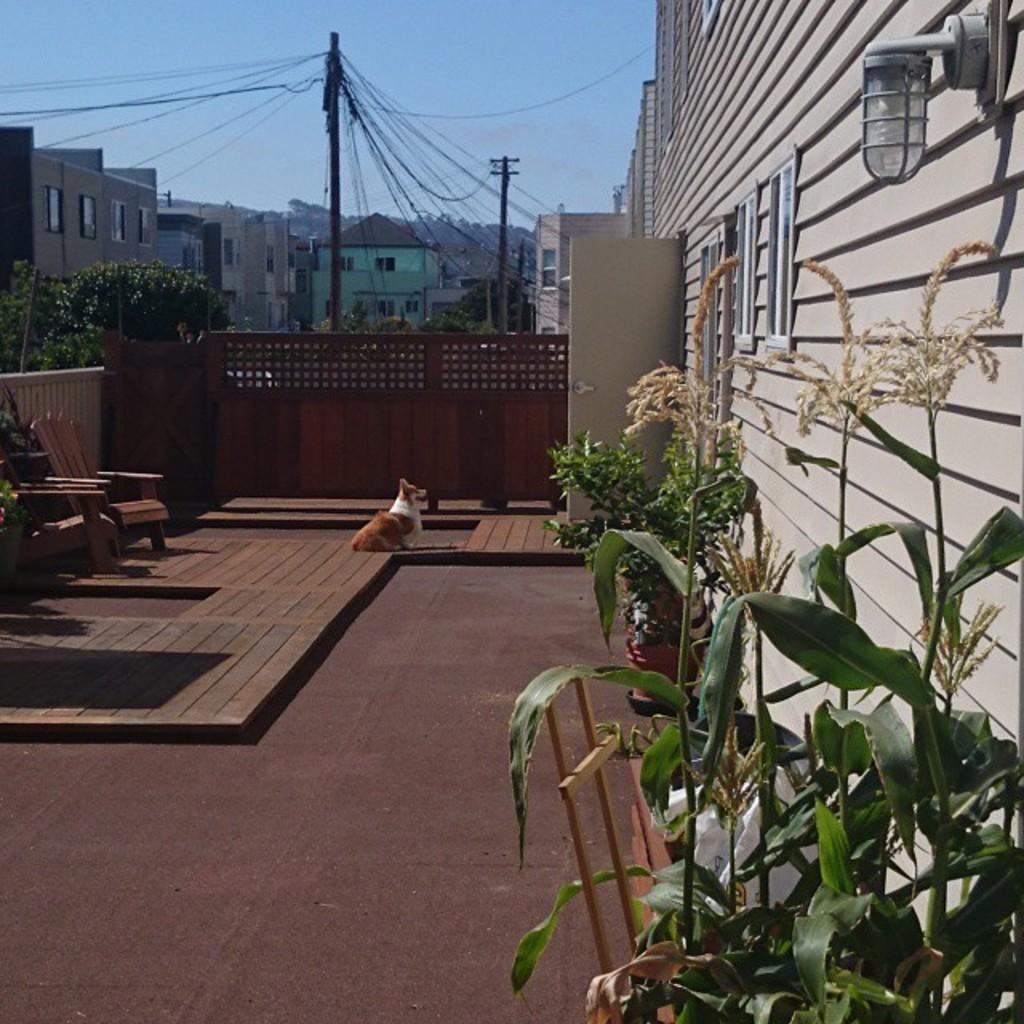Can you describe this image briefly? In this image there are few flower pots placed on the right side of the image and there is a light attached to the wall. On the left side of the image there is a chair placed. In the center of the image there is a dog sitting on the floor. In the background we can see few buildings and an electric pole with many wires. 